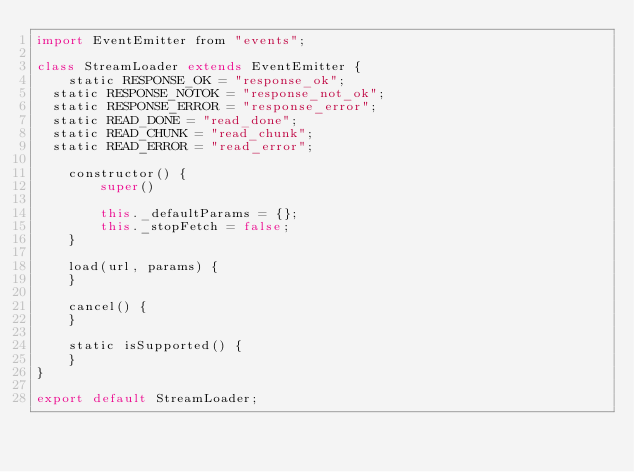Convert code to text. <code><loc_0><loc_0><loc_500><loc_500><_JavaScript_>import EventEmitter from "events";

class StreamLoader extends EventEmitter {
    static RESPONSE_OK = "response_ok";
	static RESPONSE_NOTOK = "response_not_ok";
	static RESPONSE_ERROR = "response_error";
	static READ_DONE = "read_done";
	static READ_CHUNK = "read_chunk";
	static READ_ERROR = "read_error";

    constructor() {
        super()

        this._defaultParams = {};
        this._stopFetch = false;
    }

    load(url, params) {
    }

    cancel() {
    }

    static isSupported() {
    }
}

export default StreamLoader;
</code> 